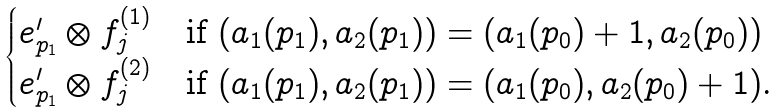Convert formula to latex. <formula><loc_0><loc_0><loc_500><loc_500>\begin{cases} e ^ { \prime } _ { p _ { 1 } } \otimes f ^ { ( 1 ) } _ { j } & \text {if $(a_{1}(p_{1}),a_{2}(p_{1}))= (a_{1}(p_{0})+1,a_{2}(p_{0}))$} \\ e ^ { \prime } _ { p _ { 1 } } \otimes f ^ { ( 2 ) } _ { j } & \text {if $(a_{1}(p_{1}),a_{2}(p_{1}))= (a_{1}(p_{0}),a_{2}(p_{0})+1)$.} \end{cases}</formula> 